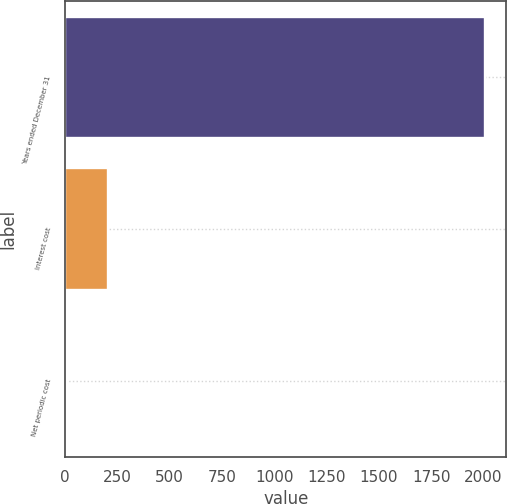Convert chart. <chart><loc_0><loc_0><loc_500><loc_500><bar_chart><fcel>Years ended December 31<fcel>Interest cost<fcel>Net periodic cost<nl><fcel>2008<fcel>204.22<fcel>3.8<nl></chart> 